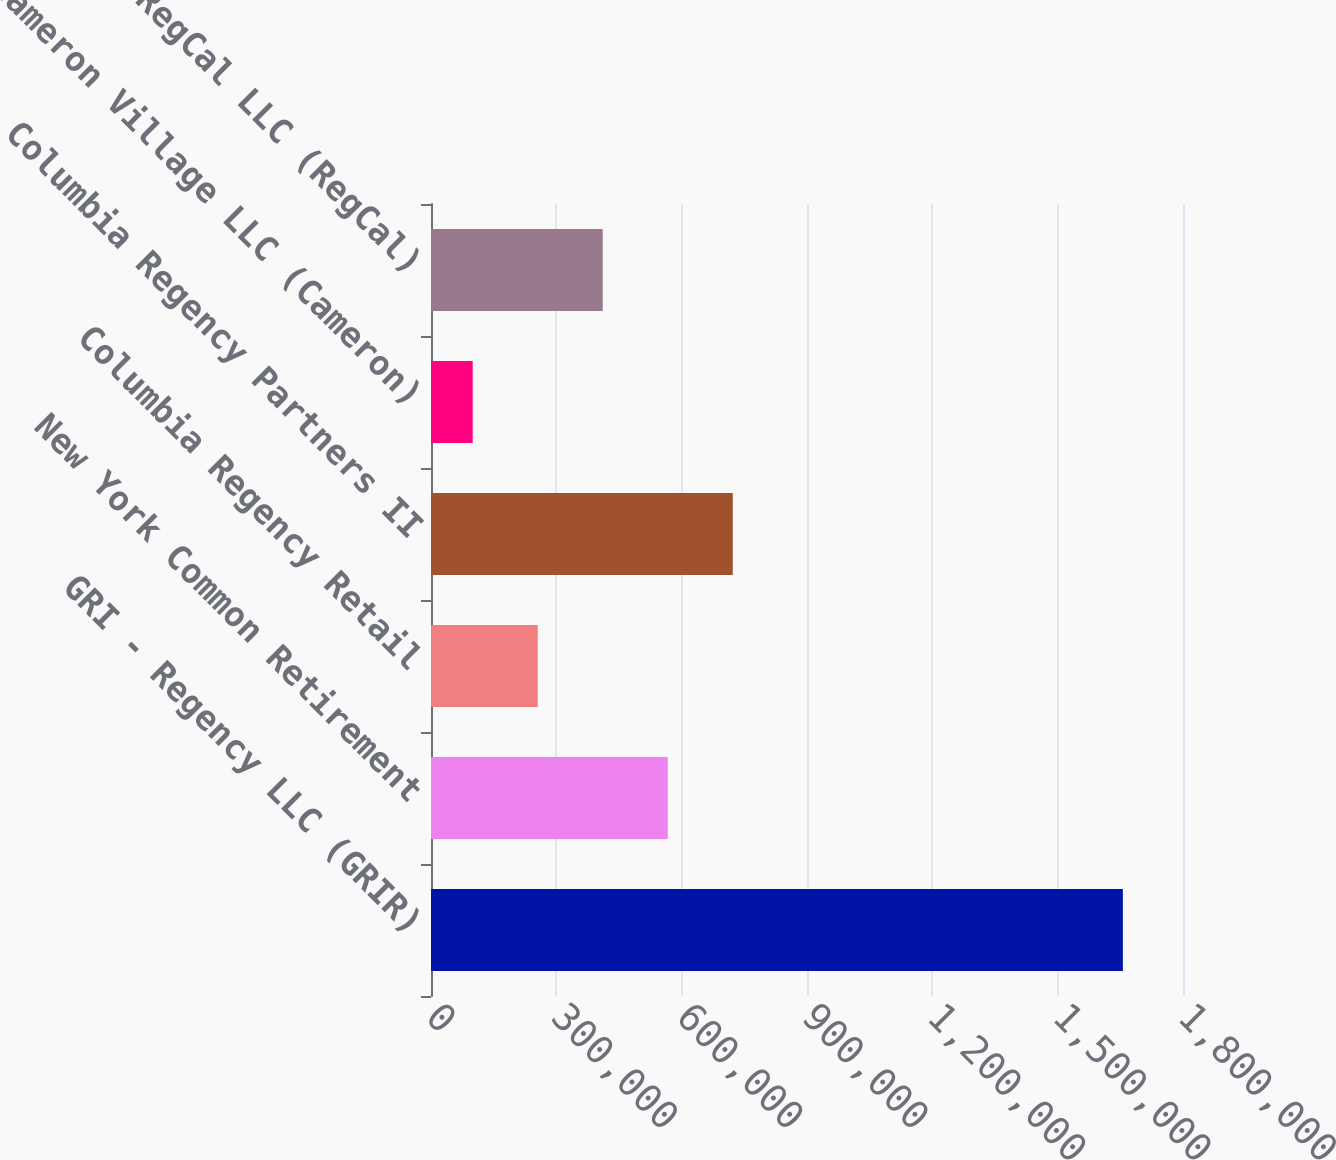Convert chart to OTSL. <chart><loc_0><loc_0><loc_500><loc_500><bar_chart><fcel>GRI - Regency LLC (GRIR)<fcel>New York Common Retirement<fcel>Columbia Regency Retail<fcel>Columbia Regency Partners II<fcel>Cameron Village LLC (Cameron)<fcel>RegCal LLC (RegCal)<nl><fcel>1.65607e+06<fcel>566686<fcel>255434<fcel>722312<fcel>99808<fcel>411060<nl></chart> 